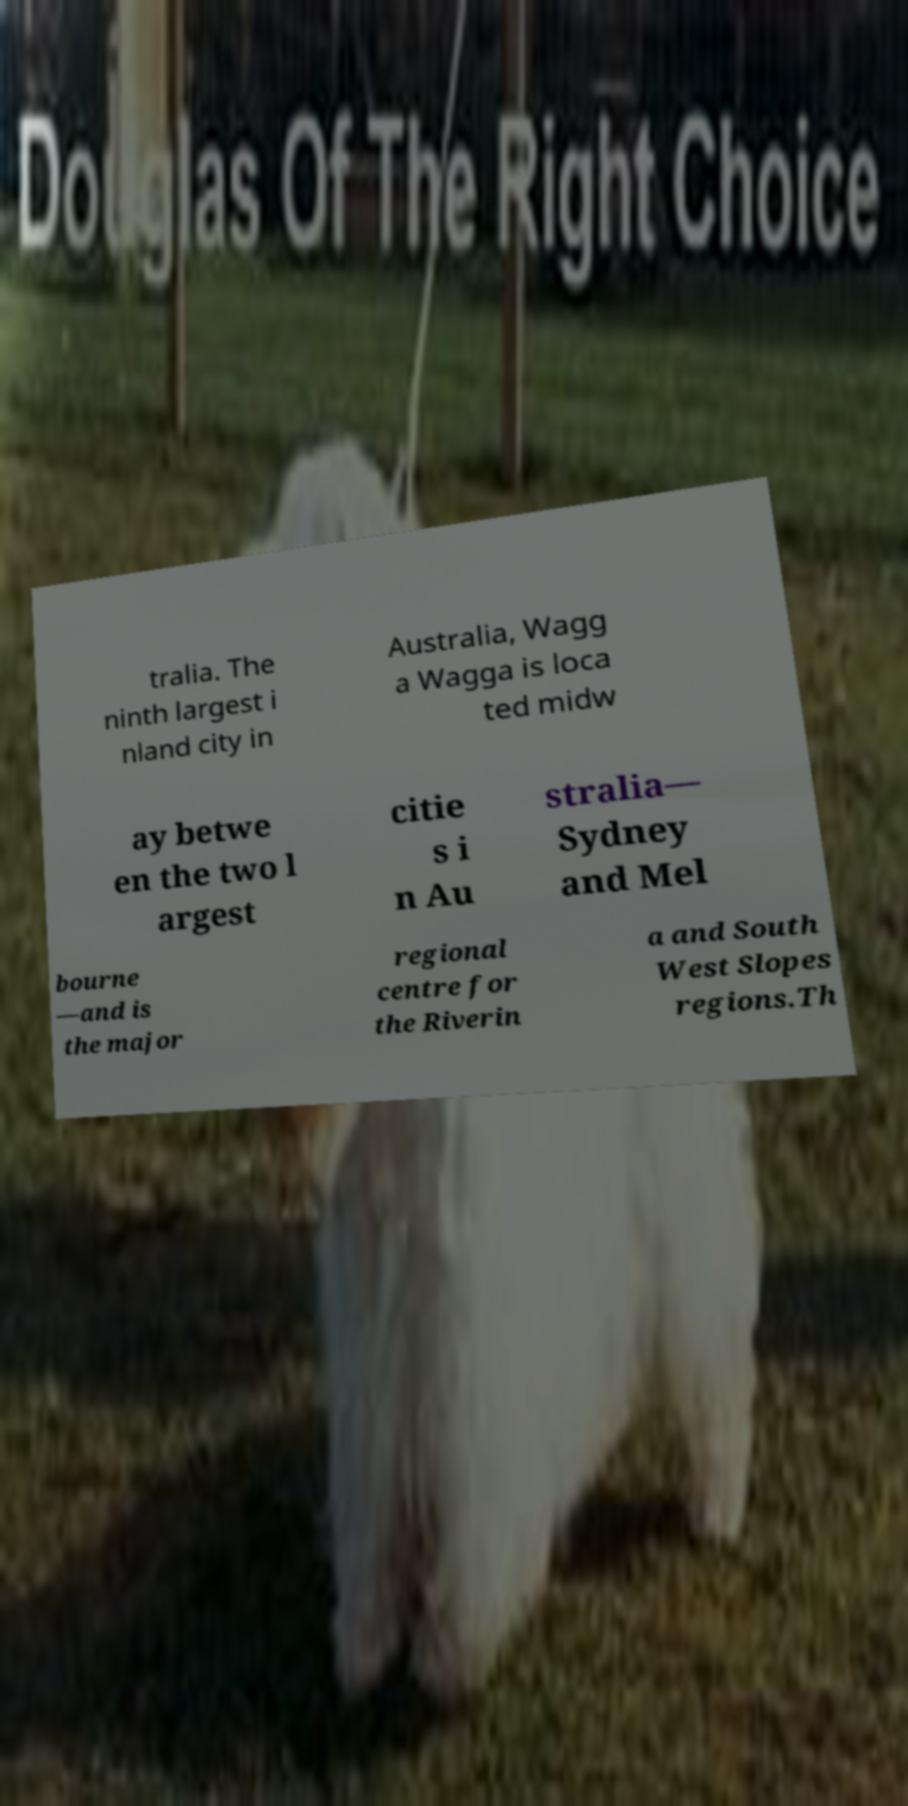There's text embedded in this image that I need extracted. Can you transcribe it verbatim? tralia. The ninth largest i nland city in Australia, Wagg a Wagga is loca ted midw ay betwe en the two l argest citie s i n Au stralia— Sydney and Mel bourne —and is the major regional centre for the Riverin a and South West Slopes regions.Th 